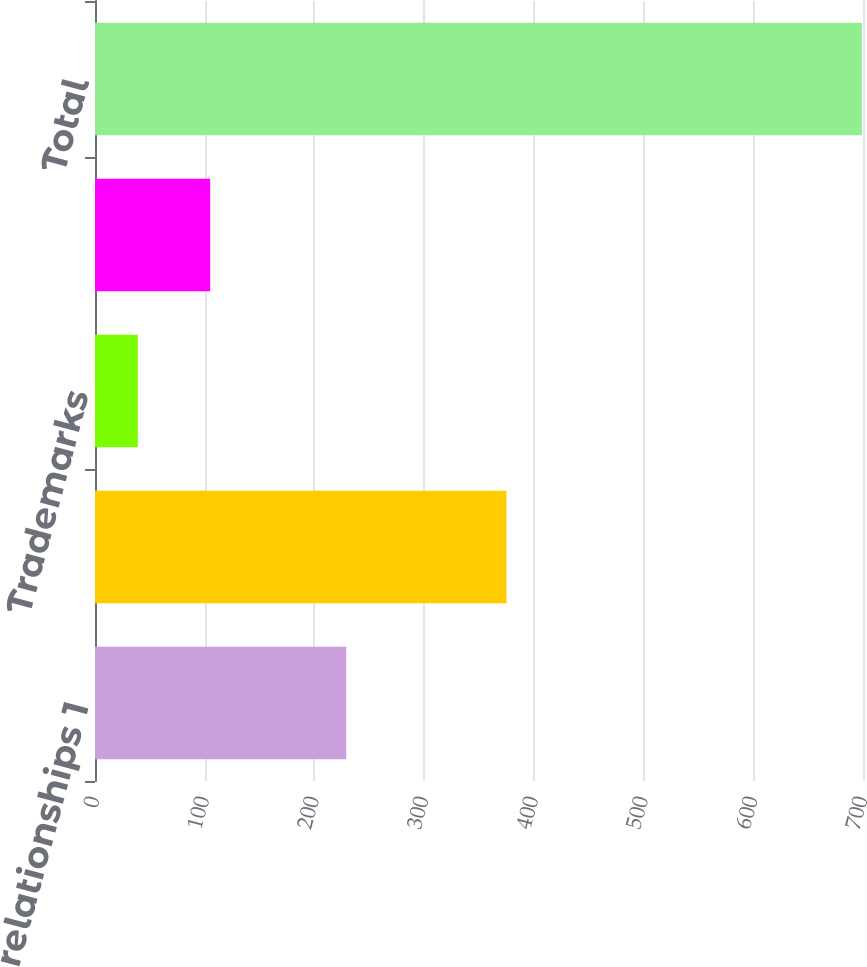<chart> <loc_0><loc_0><loc_500><loc_500><bar_chart><fcel>Customer relationships 1<fcel>Bottlers' franchise rights 1<fcel>Trademarks<fcel>Other<fcel>Total<nl><fcel>229<fcel>375<fcel>39<fcel>105<fcel>699<nl></chart> 